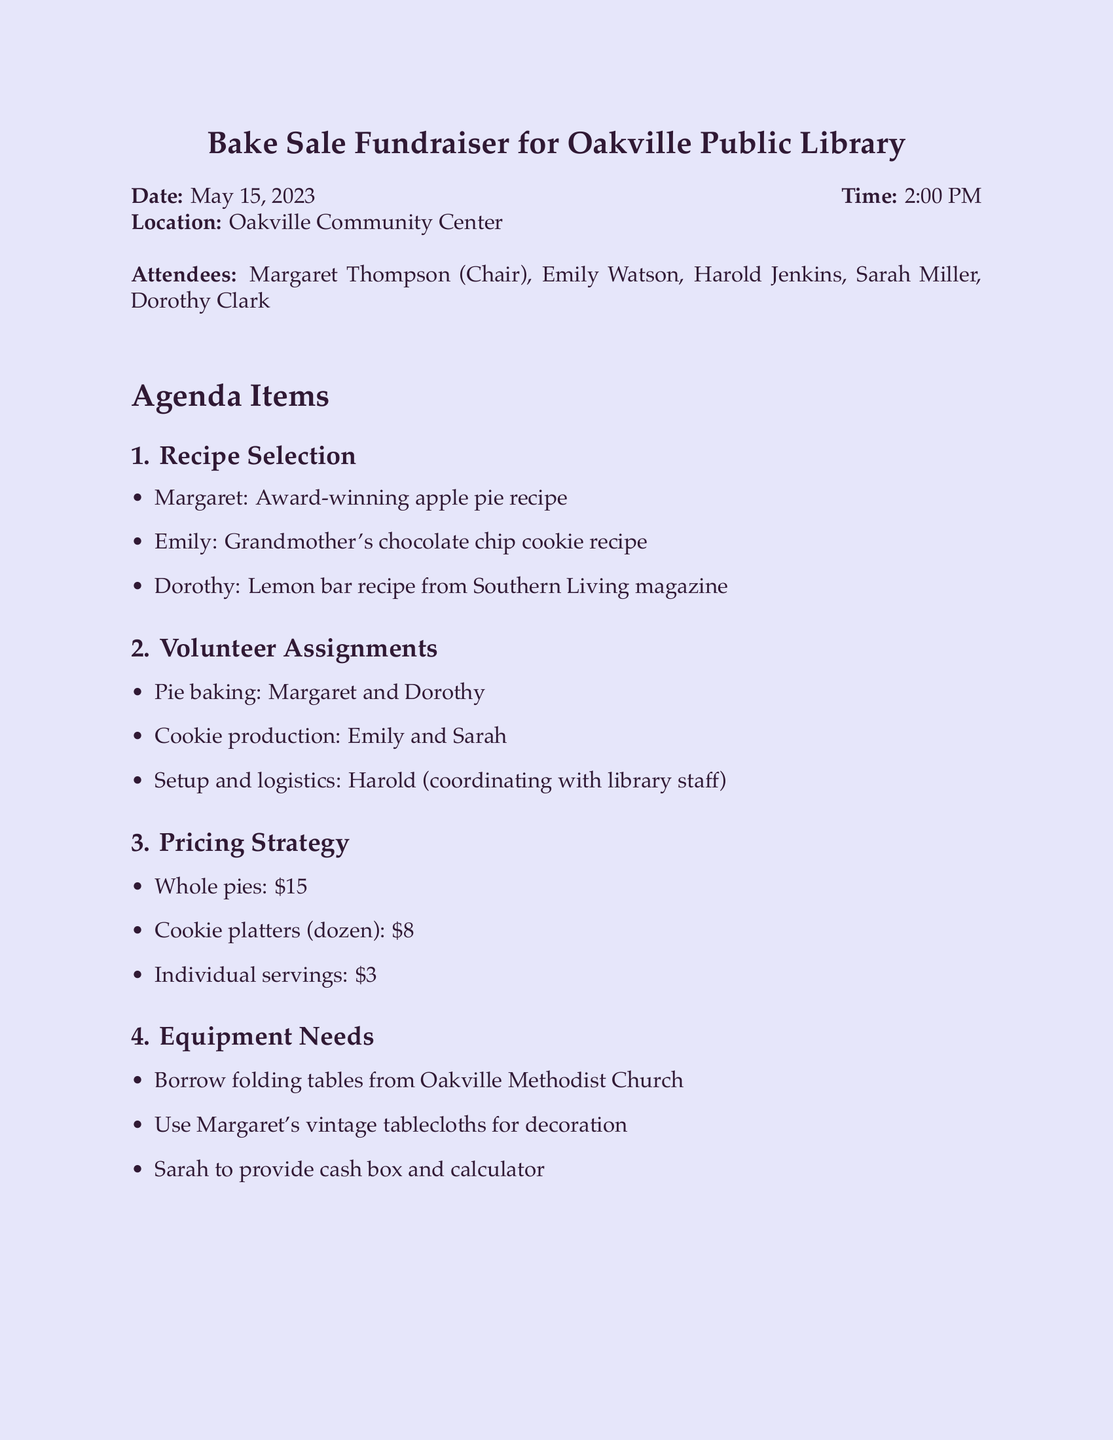What is the name of the chairperson for the meeting? The chairperson is mentioned in the list of attendees, which includes Margaret Thompson.
Answer: Margaret Thompson When is the bake sale fundraiser scheduled? The date of the event is listed under the meeting details.
Answer: May 15, 2023 What items are assigned to Margaret and Dorothy? The volunteer assignments detail that both are responsible for baking pies.
Answer: Pie baking What recipe does Emily plan to contribute? The recipe selection section specifies that Emily will bring her grandmother's chocolate chip cookie recipe.
Answer: Grandmother's chocolate chip cookie recipe What is the price of individual servings? The pricing strategy section lists the cost of individual servings.
Answer: $3 Who is tasked with confirming the table loan with the church? The action items state that Harold is responsible for confirming the table loan.
Answer: Harold What type of materials will be used for decoration? The equipment needs section mentions the use of vintage tablecloths for decoration.
Answer: Vintage tablecloths What platform will Sarah use to post about the event? The marketing section specifies that Sarah will post the event on the library's Facebook page.
Answer: Library's Facebook page When is the next meeting scheduled? The next meeting details are provided at the end of the document, specifying the date and time.
Answer: May 29, 2023, 2:00 PM 